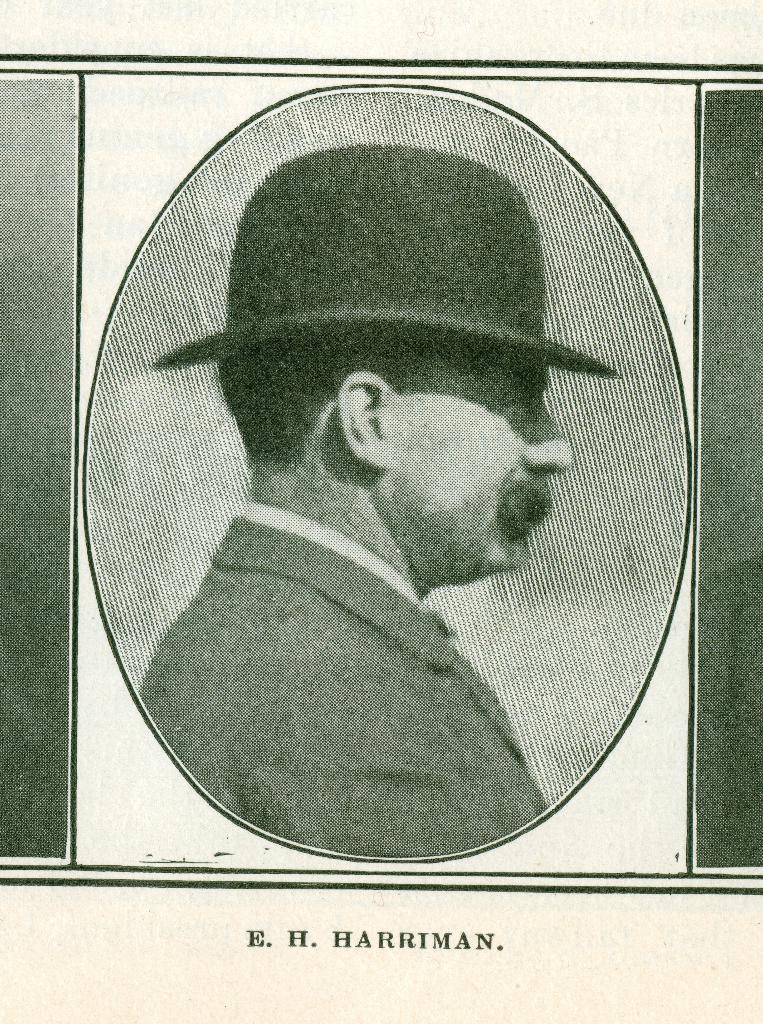What is the main subject of the image? There is a picture of a person in the image. What is the person wearing in the image? The person is wearing a black dress and a black hat. Is there any text present in the image? Yes, there is text written at the bottom of the image. Can you tell me how much powder the person is carrying in the image? There is no mention of powder or any indication that the person is carrying any in the image. 